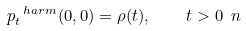Convert formula to latex. <formula><loc_0><loc_0><loc_500><loc_500>p ^ { \ h a r m } _ { t } ( 0 , 0 ) = \rho ( t ) , \quad t > 0 \ n</formula> 